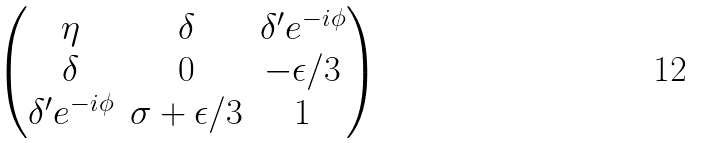<formula> <loc_0><loc_0><loc_500><loc_500>\begin{pmatrix} \eta & \delta & \delta ^ { \prime } e ^ { - i \phi } \\ \delta & 0 & - \epsilon / 3 \\ \delta ^ { \prime } e ^ { - i \phi } & \sigma + \epsilon / 3 & 1 \end{pmatrix}</formula> 